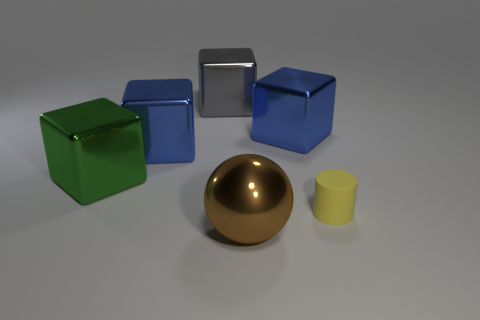How do the objects in the image vary in size? In the image, there's a noticeable variation in size among the objects. The golden sphere and the blue cubes are larger and seem to be roughly the same size. The silver cube looks slightly smaller than these objects. The green cube is of a similar size to the silver cube but still may be slightly larger, and the yellow cylinder is the smallest object present.  Could you arrange the objects by size from smallest to largest? Certainly, starting with the smallest, we have the yellow cylinder, followed by the silver cube. The green cube comes next, appearing slightly larger. The blue cubes and the golden sphere are the largest, and while they are similar in size, the golden sphere might be slightly larger due to its complete form. 